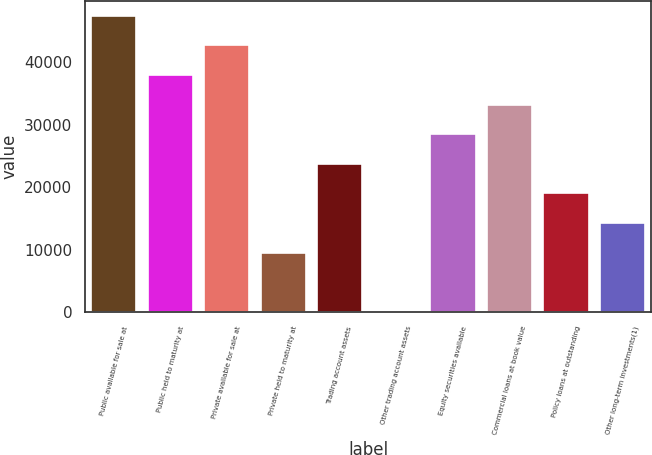<chart> <loc_0><loc_0><loc_500><loc_500><bar_chart><fcel>Public available for sale at<fcel>Public held to maturity at<fcel>Private available for sale at<fcel>Private held to maturity at<fcel>Trading account assets<fcel>Other trading account assets<fcel>Equity securities available<fcel>Commercial loans at book value<fcel>Policy loans at outstanding<fcel>Other long-term investments(1)<nl><fcel>47497<fcel>38003.2<fcel>42750.1<fcel>9521.8<fcel>23762.5<fcel>28<fcel>28509.4<fcel>33256.3<fcel>19015.6<fcel>14268.7<nl></chart> 